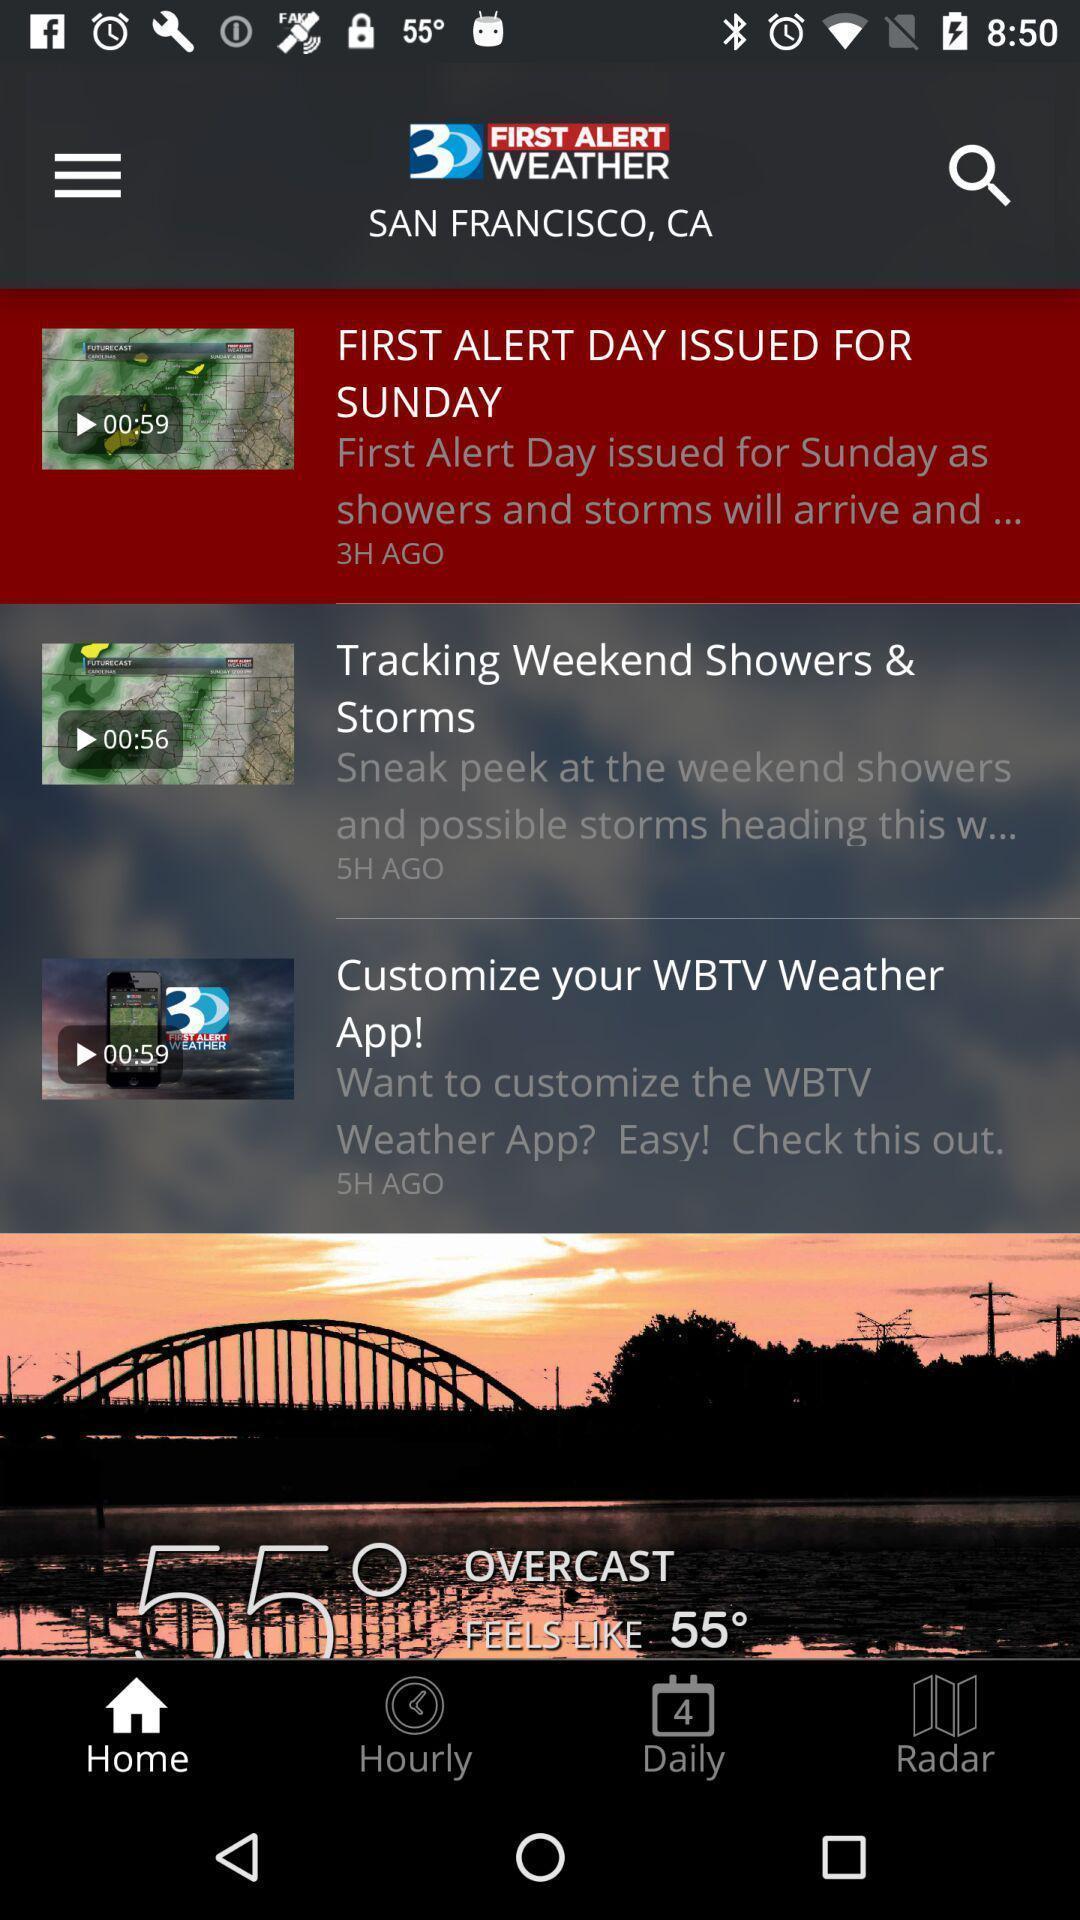Summarize the information in this screenshot. Page showing news feed for weather forecast app. 